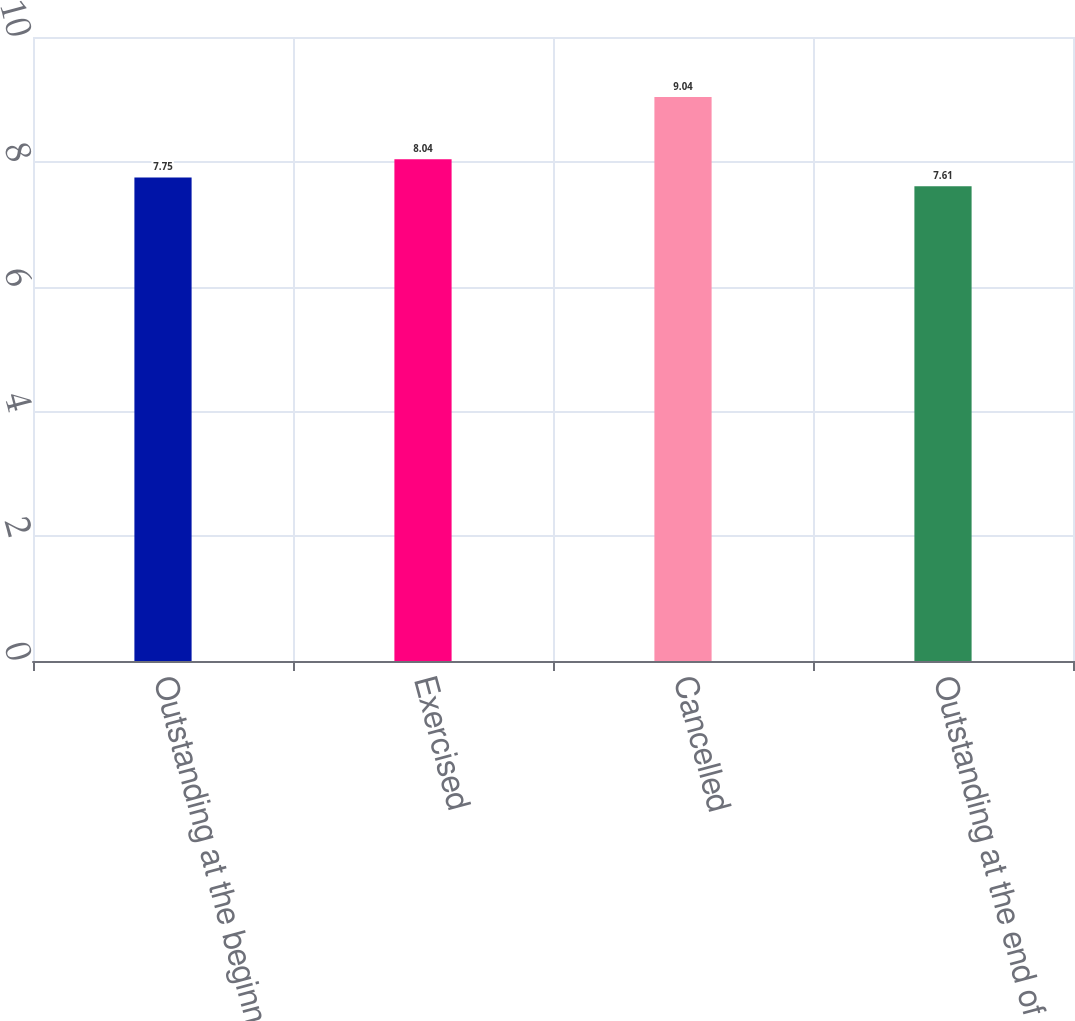<chart> <loc_0><loc_0><loc_500><loc_500><bar_chart><fcel>Outstanding at the beginning<fcel>Exercised<fcel>Cancelled<fcel>Outstanding at the end of the<nl><fcel>7.75<fcel>8.04<fcel>9.04<fcel>7.61<nl></chart> 